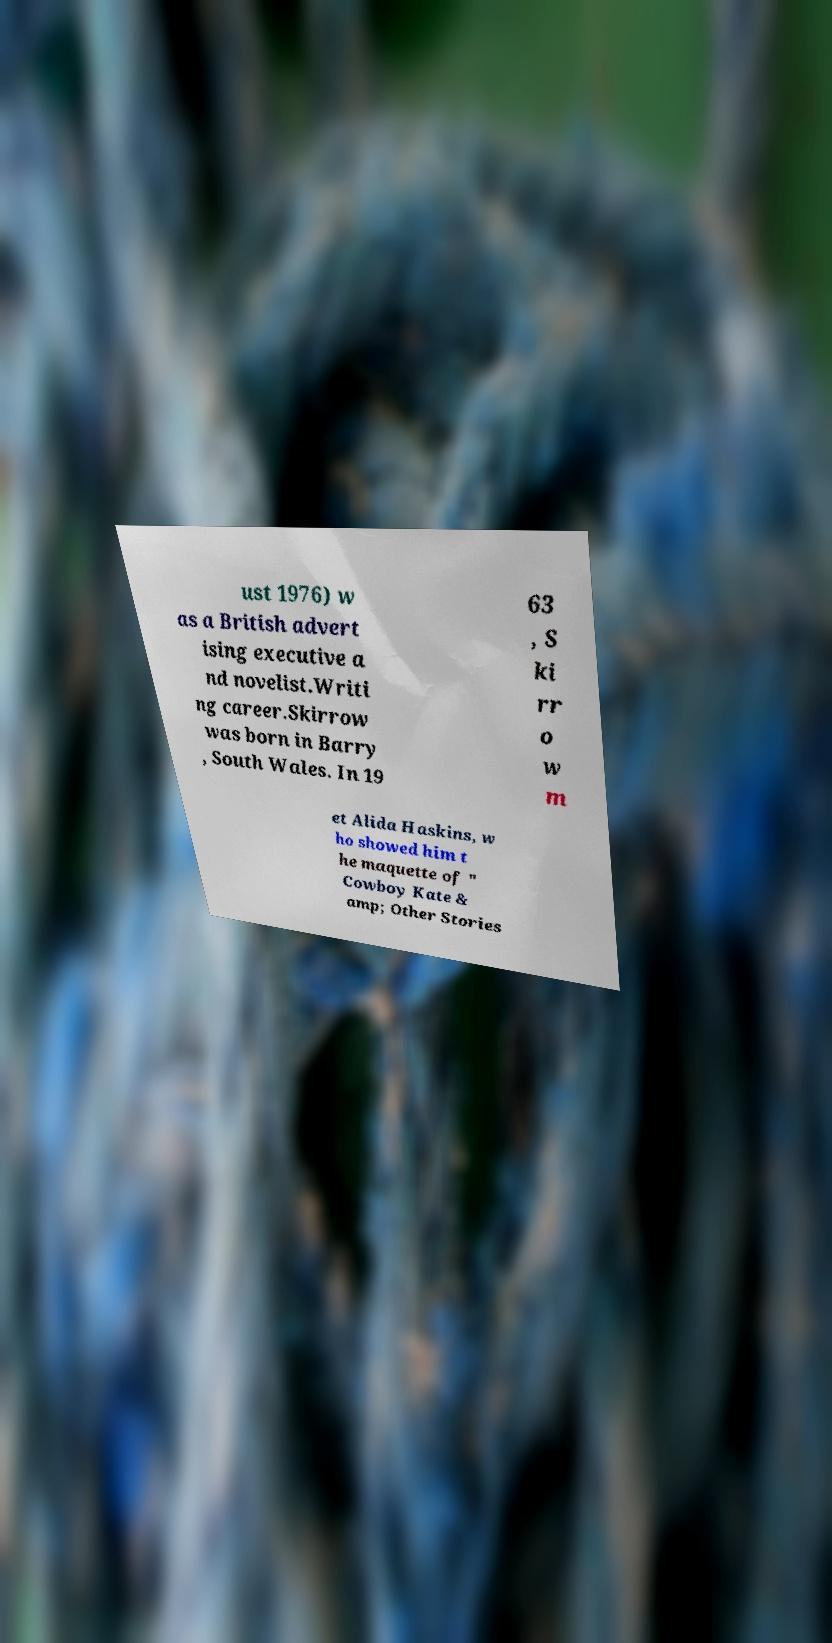Can you accurately transcribe the text from the provided image for me? ust 1976) w as a British advert ising executive a nd novelist.Writi ng career.Skirrow was born in Barry , South Wales. In 19 63 , S ki rr o w m et Alida Haskins, w ho showed him t he maquette of " Cowboy Kate & amp; Other Stories 